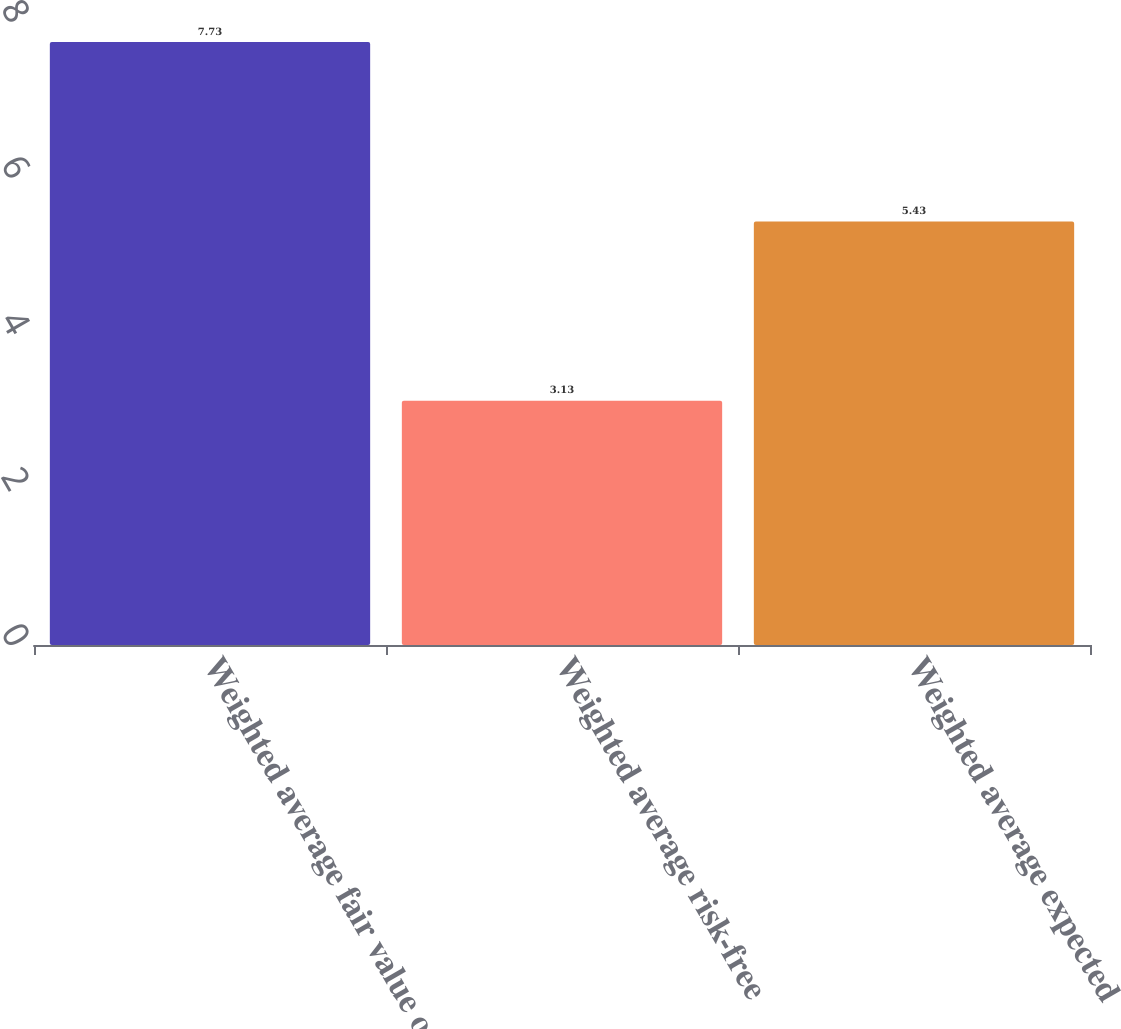Convert chart. <chart><loc_0><loc_0><loc_500><loc_500><bar_chart><fcel>Weighted average fair value of<fcel>Weighted average risk-free<fcel>Weighted average expected<nl><fcel>7.73<fcel>3.13<fcel>5.43<nl></chart> 